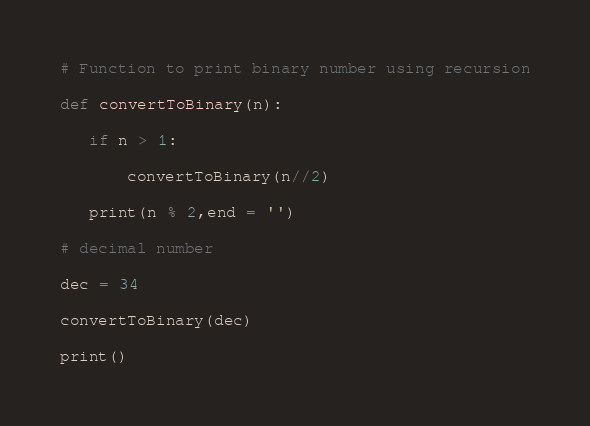Convert code to text. <code><loc_0><loc_0><loc_500><loc_500><_Python_># Function to print binary number using recursion

def convertToBinary(n):

   if n > 1:

       convertToBinary(n//2)

   print(n % 2,end = '')

# decimal number

dec = 34

convertToBinary(dec)

print()
</code> 